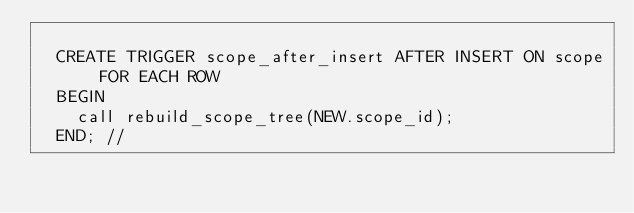<code> <loc_0><loc_0><loc_500><loc_500><_SQL_>
	CREATE TRIGGER scope_after_insert AFTER INSERT ON scope FOR EACH ROW
	BEGIN
	  call rebuild_scope_tree(NEW.scope_id);
	END; //
</code> 